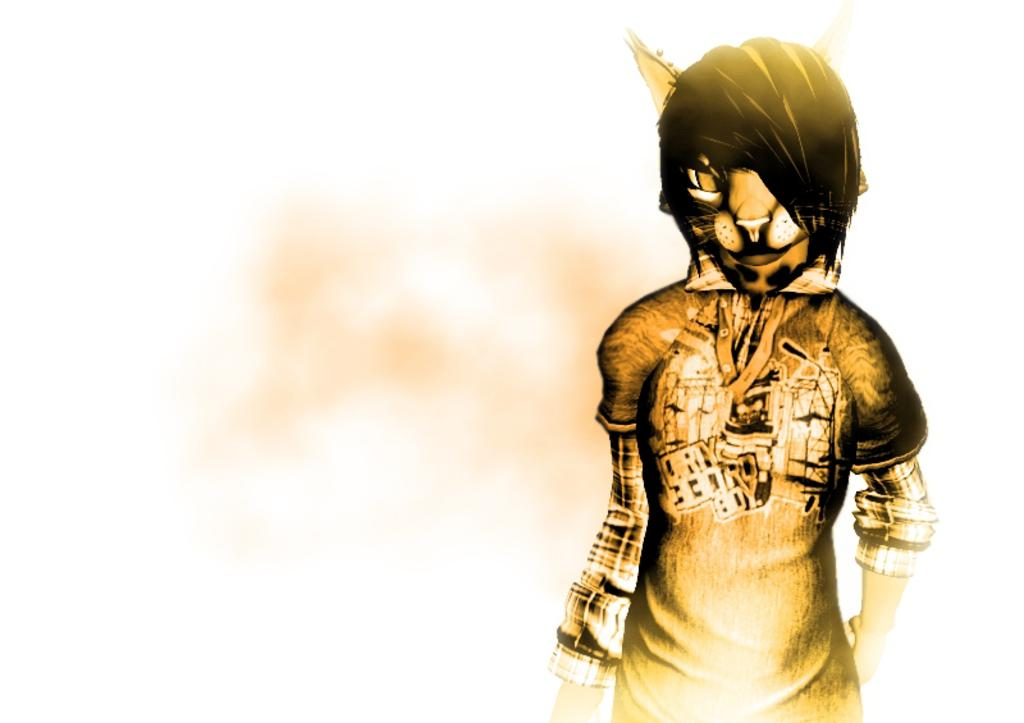What is the main subject in the foreground of the image? There is an animated picture in the foreground of the image. What type of silverware is visible in the image? There is no silverware present in the image; it features an animated picture in the foreground. 